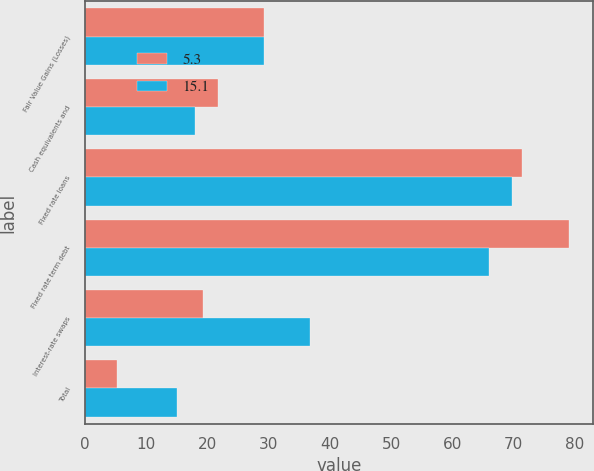Convert chart to OTSL. <chart><loc_0><loc_0><loc_500><loc_500><stacked_bar_chart><ecel><fcel>Fair Value Gains (Losses)<fcel>Cash equivalents and<fcel>Fixed rate loans<fcel>Fixed rate term debt<fcel>Interest-rate swaps<fcel>Total<nl><fcel>5.3<fcel>29.25<fcel>21.7<fcel>71.3<fcel>79<fcel>19.3<fcel>5.3<nl><fcel>15.1<fcel>29.25<fcel>18<fcel>69.7<fcel>66<fcel>36.8<fcel>15.1<nl></chart> 